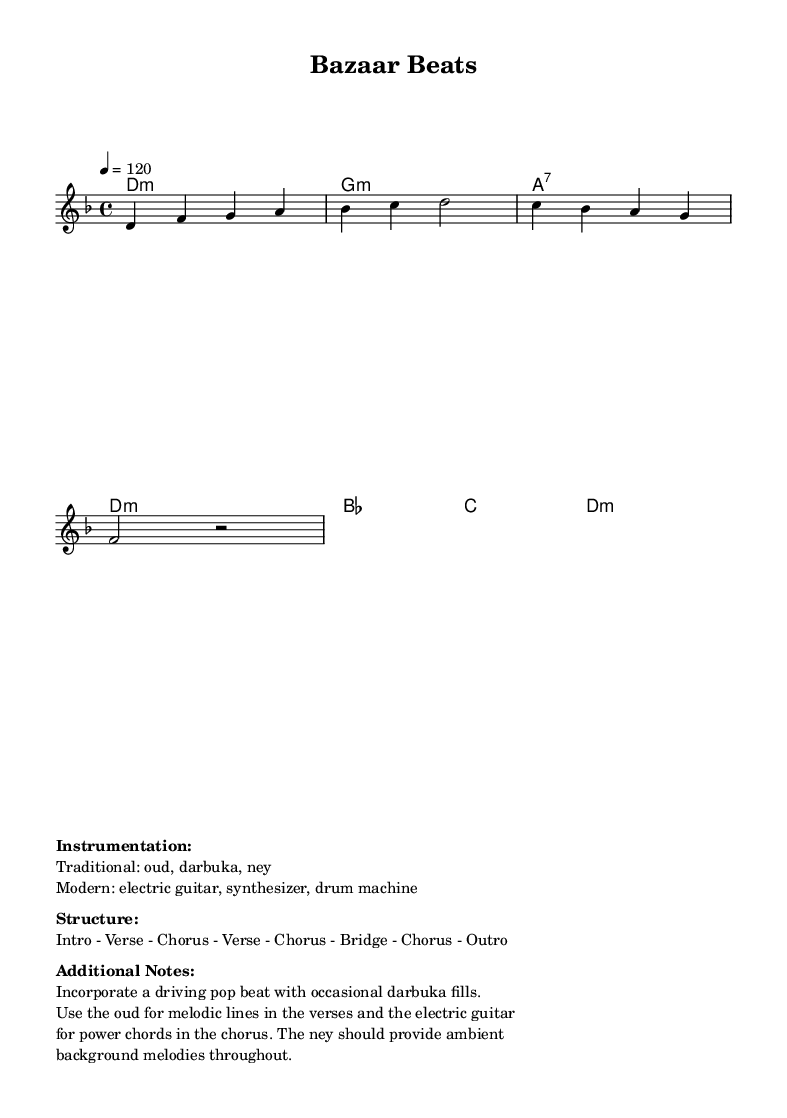What is the key signature of this music? The key signature indicated in the sheet music is D minor, which has one flat (B♭).
Answer: D minor What is the time signature of this music? The time signature shown in the music is 4/4, meaning there are four beats in each measure and the quarter note gets one beat.
Answer: 4/4 What is the tempo marking for the music? The tempo marking in the score shows a speed of 120 beats per minute, meaning the music should be played at a moderate pace.
Answer: 120 How many distinct sections are in the structure of the piece? Referring to the structure listed in the markup, it details eight sections: Intro, Verse, Chorus, Verse, Chorus, Bridge, Chorus, Outro. Counting these gives a total of eight sections in the composition.
Answer: Eight What traditional instruments are used in this piece? The markup specifies three traditional instruments: oud, darbuka, and ney. These instruments contribute to the fusion of Middle Eastern sounds.
Answer: Oud, darbuka, ney What modern instruments are incorporated into the composition? The sheet music mentions the inclusion of an electric guitar, synthesizer, and drum machine as the modern instruments that complement the traditional sounds.
Answer: Electric guitar, synthesizer, drum machine What type of rhythmic elements are suggested for the piece? The additional notes indicate a driving pop beat with occasional darbuka fills, emphasizing the blend of traditional and modern rhythms.
Answer: Driving pop beat, darbuka fills 